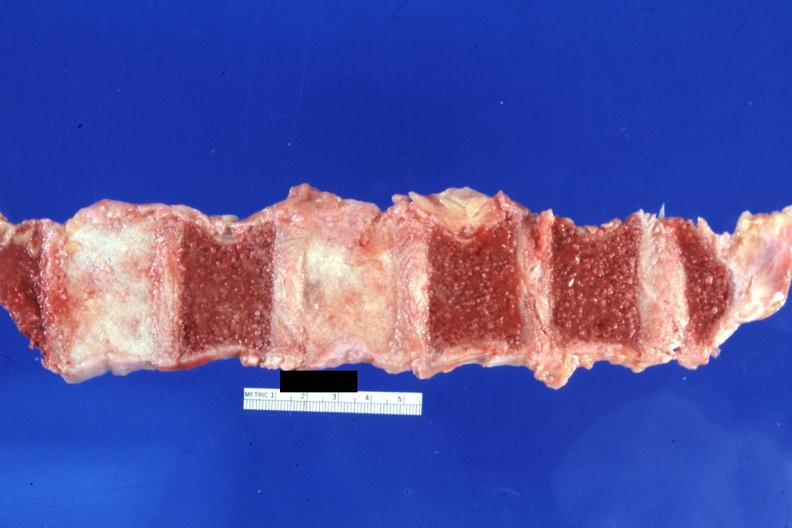do typical ivory vertebra not have history at this time diagnosis?
Answer the question using a single word or phrase. Yes 